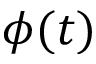Convert formula to latex. <formula><loc_0><loc_0><loc_500><loc_500>\phi ( t )</formula> 